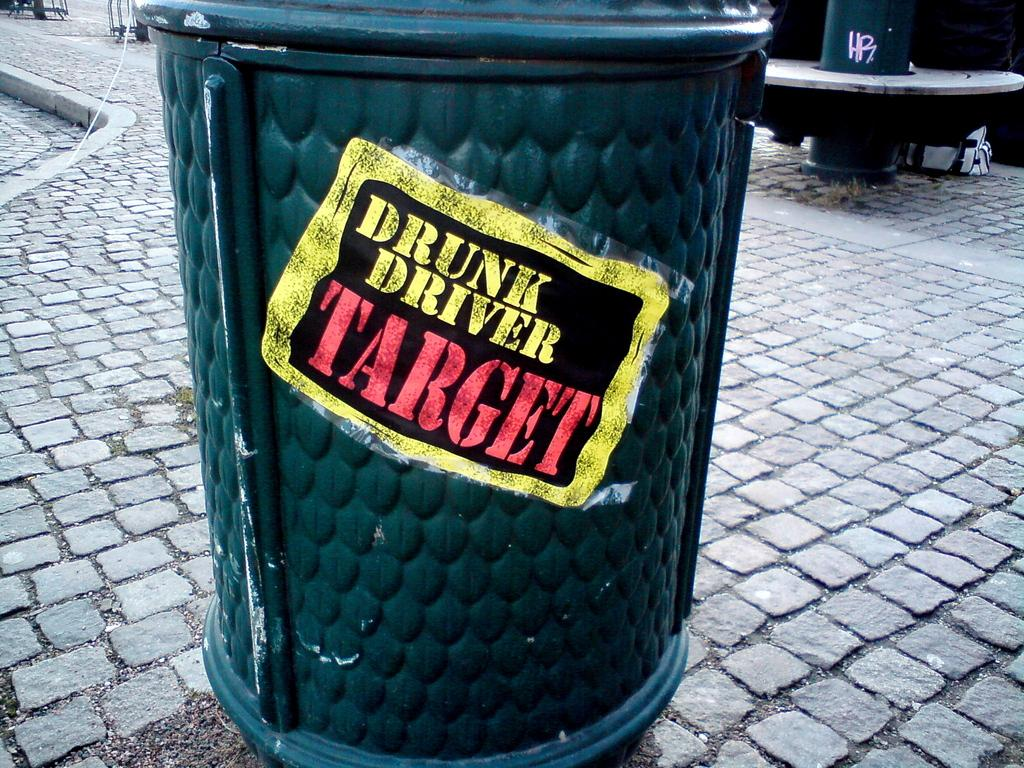Provide a one-sentence caption for the provided image. A garbage receptacle has a sticker on it which reads "Drunk Driver Target.". 